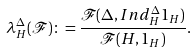<formula> <loc_0><loc_0><loc_500><loc_500>\lambda _ { H } ^ { \Delta } ( \mathcal { F } ) \colon = \frac { \mathcal { F } ( \Delta , I n d _ { H } ^ { \Delta } 1 _ { H } ) } { \mathcal { F } ( H , 1 _ { H } ) } .</formula> 